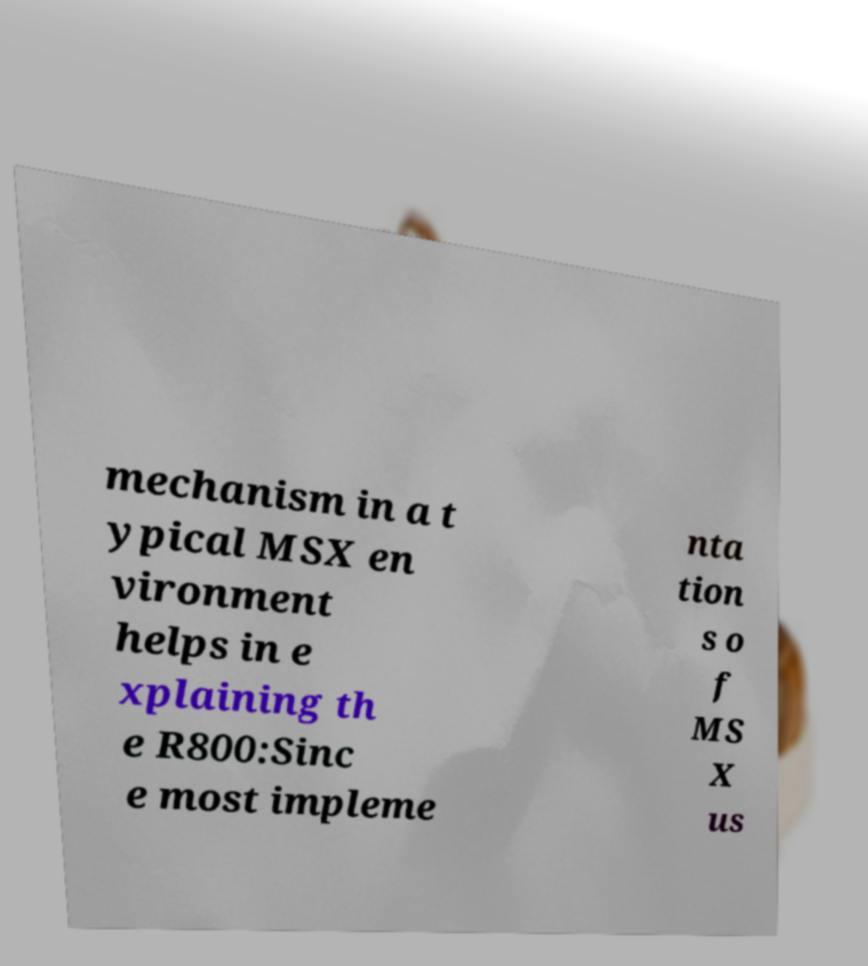Can you accurately transcribe the text from the provided image for me? mechanism in a t ypical MSX en vironment helps in e xplaining th e R800:Sinc e most impleme nta tion s o f MS X us 